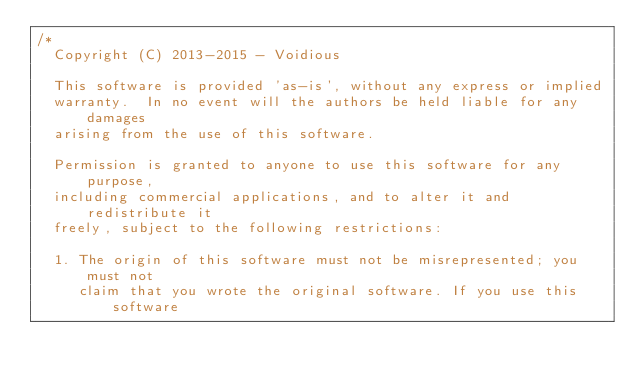<code> <loc_0><loc_0><loc_500><loc_500><_C++_>/*
  Copyright (C) 2013-2015 - Voidious

  This software is provided 'as-is', without any express or implied
  warranty.  In no event will the authors be held liable for any damages
  arising from the use of this software.

  Permission is granted to anyone to use this software for any purpose,
  including commercial applications, and to alter it and redistribute it
  freely, subject to the following restrictions:

  1. The origin of this software must not be misrepresented; you must not
     claim that you wrote the original software. If you use this software</code> 